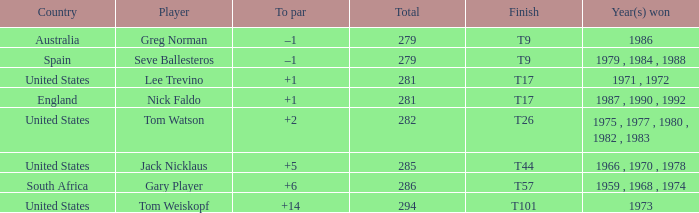What country is Greg Norman from? Australia. 